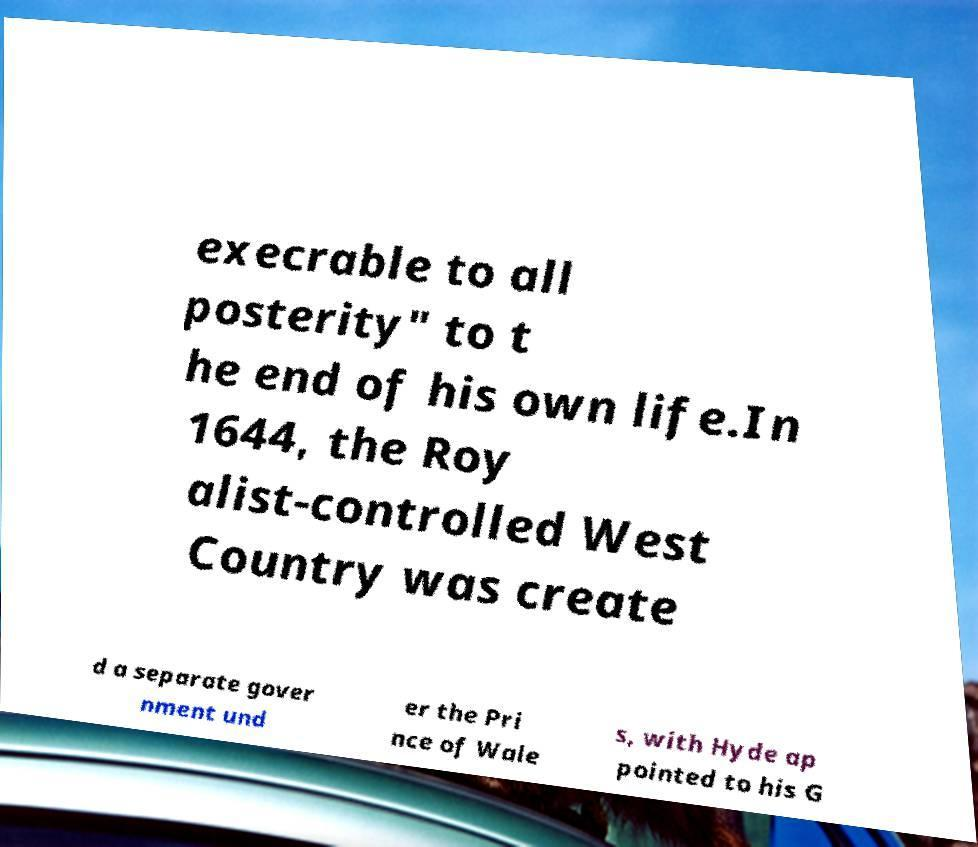Please read and relay the text visible in this image. What does it say? execrable to all posterity" to t he end of his own life.In 1644, the Roy alist-controlled West Country was create d a separate gover nment und er the Pri nce of Wale s, with Hyde ap pointed to his G 